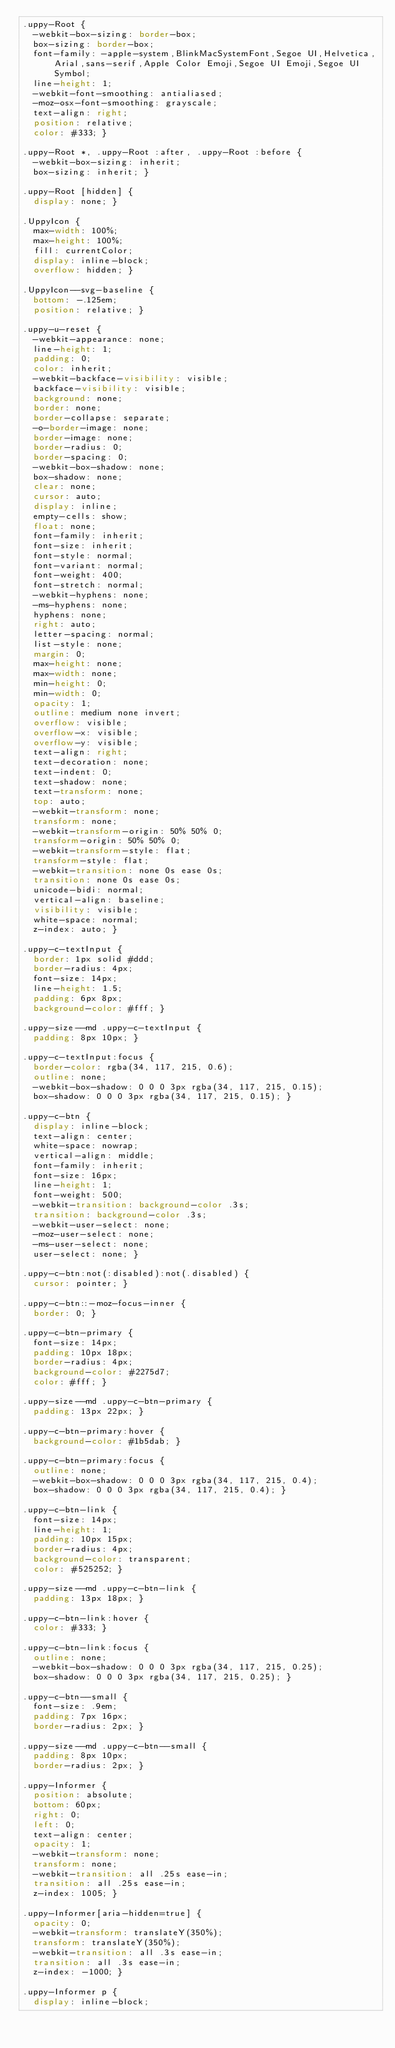<code> <loc_0><loc_0><loc_500><loc_500><_CSS_>.uppy-Root {
  -webkit-box-sizing: border-box;
  box-sizing: border-box;
  font-family: -apple-system,BlinkMacSystemFont,Segoe UI,Helvetica,Arial,sans-serif,Apple Color Emoji,Segoe UI Emoji,Segoe UI Symbol;
  line-height: 1;
  -webkit-font-smoothing: antialiased;
  -moz-osx-font-smoothing: grayscale;
  text-align: right;
  position: relative;
  color: #333; }

.uppy-Root *, .uppy-Root :after, .uppy-Root :before {
  -webkit-box-sizing: inherit;
  box-sizing: inherit; }

.uppy-Root [hidden] {
  display: none; }

.UppyIcon {
  max-width: 100%;
  max-height: 100%;
  fill: currentColor;
  display: inline-block;
  overflow: hidden; }

.UppyIcon--svg-baseline {
  bottom: -.125em;
  position: relative; }

.uppy-u-reset {
  -webkit-appearance: none;
  line-height: 1;
  padding: 0;
  color: inherit;
  -webkit-backface-visibility: visible;
  backface-visibility: visible;
  background: none;
  border: none;
  border-collapse: separate;
  -o-border-image: none;
  border-image: none;
  border-radius: 0;
  border-spacing: 0;
  -webkit-box-shadow: none;
  box-shadow: none;
  clear: none;
  cursor: auto;
  display: inline;
  empty-cells: show;
  float: none;
  font-family: inherit;
  font-size: inherit;
  font-style: normal;
  font-variant: normal;
  font-weight: 400;
  font-stretch: normal;
  -webkit-hyphens: none;
  -ms-hyphens: none;
  hyphens: none;
  right: auto;
  letter-spacing: normal;
  list-style: none;
  margin: 0;
  max-height: none;
  max-width: none;
  min-height: 0;
  min-width: 0;
  opacity: 1;
  outline: medium none invert;
  overflow: visible;
  overflow-x: visible;
  overflow-y: visible;
  text-align: right;
  text-decoration: none;
  text-indent: 0;
  text-shadow: none;
  text-transform: none;
  top: auto;
  -webkit-transform: none;
  transform: none;
  -webkit-transform-origin: 50% 50% 0;
  transform-origin: 50% 50% 0;
  -webkit-transform-style: flat;
  transform-style: flat;
  -webkit-transition: none 0s ease 0s;
  transition: none 0s ease 0s;
  unicode-bidi: normal;
  vertical-align: baseline;
  visibility: visible;
  white-space: normal;
  z-index: auto; }

.uppy-c-textInput {
  border: 1px solid #ddd;
  border-radius: 4px;
  font-size: 14px;
  line-height: 1.5;
  padding: 6px 8px;
  background-color: #fff; }

.uppy-size--md .uppy-c-textInput {
  padding: 8px 10px; }

.uppy-c-textInput:focus {
  border-color: rgba(34, 117, 215, 0.6);
  outline: none;
  -webkit-box-shadow: 0 0 0 3px rgba(34, 117, 215, 0.15);
  box-shadow: 0 0 0 3px rgba(34, 117, 215, 0.15); }

.uppy-c-btn {
  display: inline-block;
  text-align: center;
  white-space: nowrap;
  vertical-align: middle;
  font-family: inherit;
  font-size: 16px;
  line-height: 1;
  font-weight: 500;
  -webkit-transition: background-color .3s;
  transition: background-color .3s;
  -webkit-user-select: none;
  -moz-user-select: none;
  -ms-user-select: none;
  user-select: none; }

.uppy-c-btn:not(:disabled):not(.disabled) {
  cursor: pointer; }

.uppy-c-btn::-moz-focus-inner {
  border: 0; }

.uppy-c-btn-primary {
  font-size: 14px;
  padding: 10px 18px;
  border-radius: 4px;
  background-color: #2275d7;
  color: #fff; }

.uppy-size--md .uppy-c-btn-primary {
  padding: 13px 22px; }

.uppy-c-btn-primary:hover {
  background-color: #1b5dab; }

.uppy-c-btn-primary:focus {
  outline: none;
  -webkit-box-shadow: 0 0 0 3px rgba(34, 117, 215, 0.4);
  box-shadow: 0 0 0 3px rgba(34, 117, 215, 0.4); }

.uppy-c-btn-link {
  font-size: 14px;
  line-height: 1;
  padding: 10px 15px;
  border-radius: 4px;
  background-color: transparent;
  color: #525252; }

.uppy-size--md .uppy-c-btn-link {
  padding: 13px 18px; }

.uppy-c-btn-link:hover {
  color: #333; }

.uppy-c-btn-link:focus {
  outline: none;
  -webkit-box-shadow: 0 0 0 3px rgba(34, 117, 215, 0.25);
  box-shadow: 0 0 0 3px rgba(34, 117, 215, 0.25); }

.uppy-c-btn--small {
  font-size: .9em;
  padding: 7px 16px;
  border-radius: 2px; }

.uppy-size--md .uppy-c-btn--small {
  padding: 8px 10px;
  border-radius: 2px; }

.uppy-Informer {
  position: absolute;
  bottom: 60px;
  right: 0;
  left: 0;
  text-align: center;
  opacity: 1;
  -webkit-transform: none;
  transform: none;
  -webkit-transition: all .25s ease-in;
  transition: all .25s ease-in;
  z-index: 1005; }

.uppy-Informer[aria-hidden=true] {
  opacity: 0;
  -webkit-transform: translateY(350%);
  transform: translateY(350%);
  -webkit-transition: all .3s ease-in;
  transition: all .3s ease-in;
  z-index: -1000; }

.uppy-Informer p {
  display: inline-block;</code> 